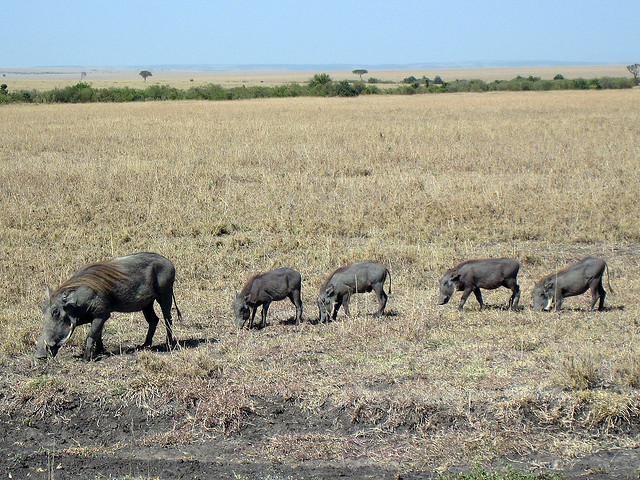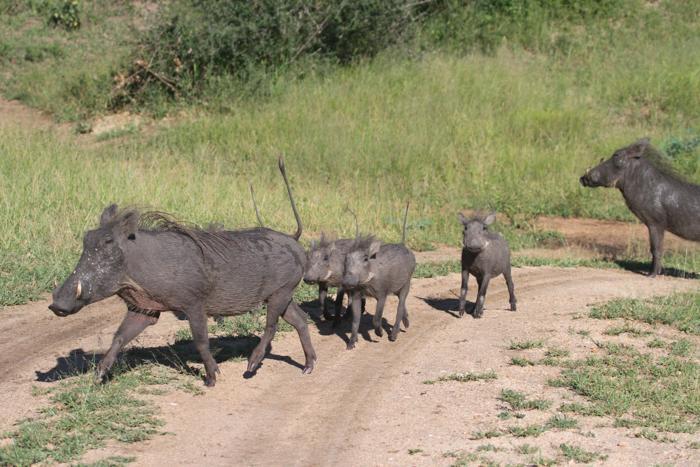The first image is the image on the left, the second image is the image on the right. For the images displayed, is the sentence "Warthogs are standing in front of a body of nearby visible water, in one image." factually correct? Answer yes or no. No. The first image is the image on the left, the second image is the image on the right. Evaluate the accuracy of this statement regarding the images: "The warthogs in one image are next to a body of water.". Is it true? Answer yes or no. No. 